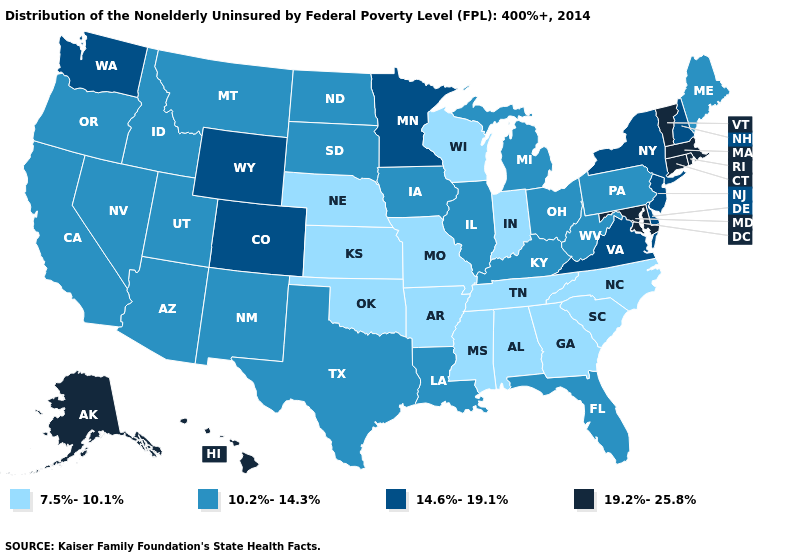Does Texas have the lowest value in the USA?
Write a very short answer. No. Which states have the lowest value in the USA?
Short answer required. Alabama, Arkansas, Georgia, Indiana, Kansas, Mississippi, Missouri, Nebraska, North Carolina, Oklahoma, South Carolina, Tennessee, Wisconsin. What is the lowest value in states that border Montana?
Short answer required. 10.2%-14.3%. What is the value of Indiana?
Short answer required. 7.5%-10.1%. What is the value of Hawaii?
Answer briefly. 19.2%-25.8%. What is the value of Florida?
Answer briefly. 10.2%-14.3%. What is the value of Arkansas?
Be succinct. 7.5%-10.1%. What is the value of North Carolina?
Concise answer only. 7.5%-10.1%. How many symbols are there in the legend?
Short answer required. 4. Does New Hampshire have the lowest value in the USA?
Short answer required. No. What is the highest value in the USA?
Give a very brief answer. 19.2%-25.8%. Does Massachusetts have the highest value in the USA?
Answer briefly. Yes. Does the first symbol in the legend represent the smallest category?
Answer briefly. Yes. Which states have the highest value in the USA?
Short answer required. Alaska, Connecticut, Hawaii, Maryland, Massachusetts, Rhode Island, Vermont. Does California have a lower value than Nevada?
Quick response, please. No. 